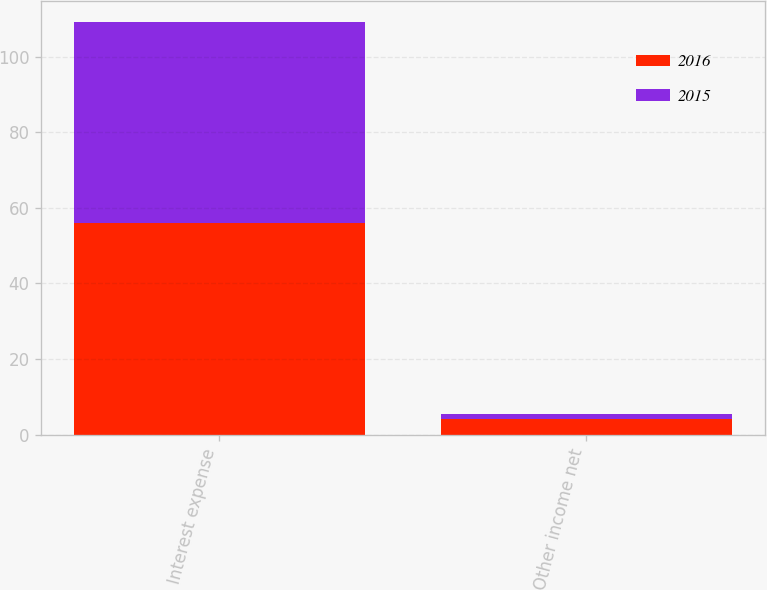Convert chart. <chart><loc_0><loc_0><loc_500><loc_500><stacked_bar_chart><ecel><fcel>Interest expense<fcel>Other income net<nl><fcel>2016<fcel>56<fcel>4.2<nl><fcel>2015<fcel>53.3<fcel>1.1<nl></chart> 